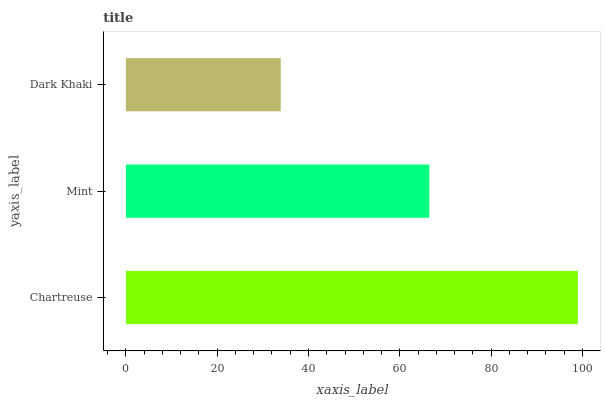Is Dark Khaki the minimum?
Answer yes or no. Yes. Is Chartreuse the maximum?
Answer yes or no. Yes. Is Mint the minimum?
Answer yes or no. No. Is Mint the maximum?
Answer yes or no. No. Is Chartreuse greater than Mint?
Answer yes or no. Yes. Is Mint less than Chartreuse?
Answer yes or no. Yes. Is Mint greater than Chartreuse?
Answer yes or no. No. Is Chartreuse less than Mint?
Answer yes or no. No. Is Mint the high median?
Answer yes or no. Yes. Is Mint the low median?
Answer yes or no. Yes. Is Dark Khaki the high median?
Answer yes or no. No. Is Dark Khaki the low median?
Answer yes or no. No. 